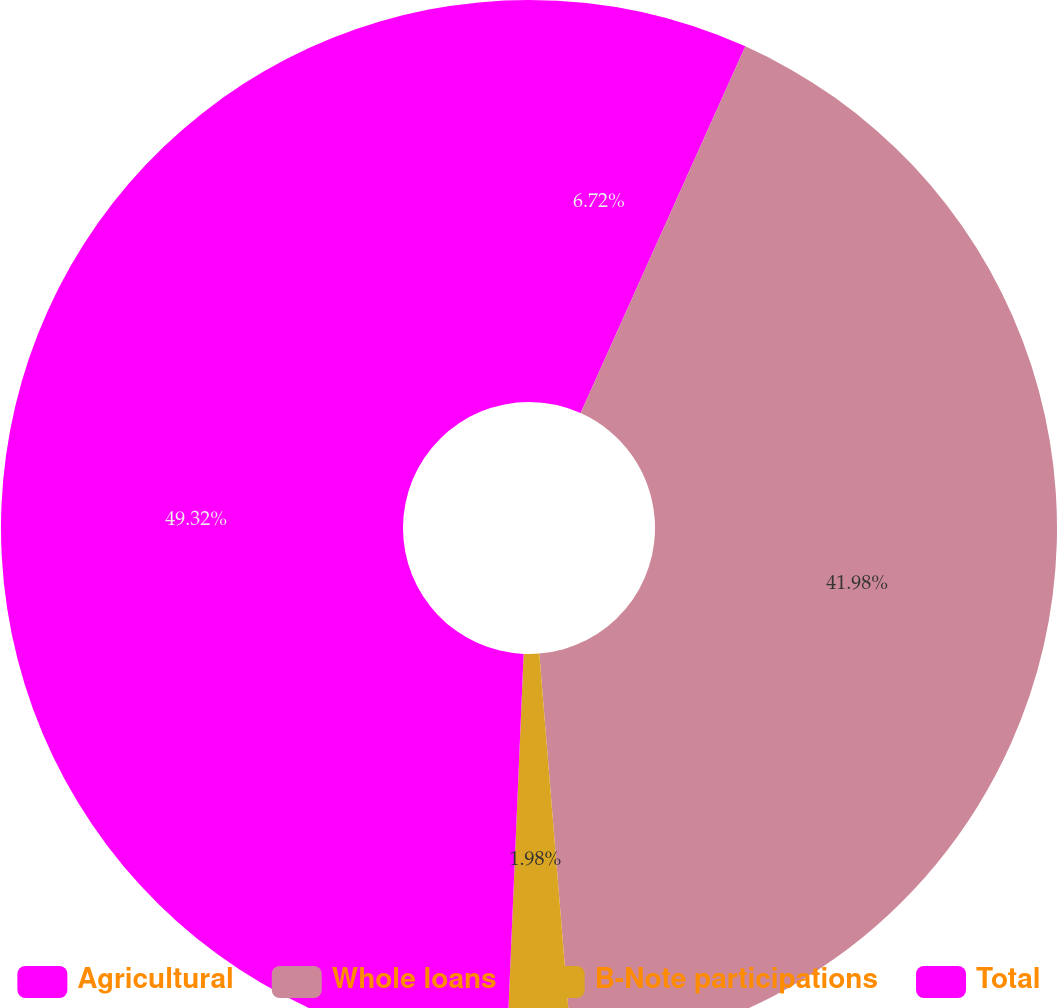Convert chart. <chart><loc_0><loc_0><loc_500><loc_500><pie_chart><fcel>Agricultural<fcel>Whole loans<fcel>B-Note participations<fcel>Total<nl><fcel>6.72%<fcel>41.98%<fcel>1.98%<fcel>49.32%<nl></chart> 